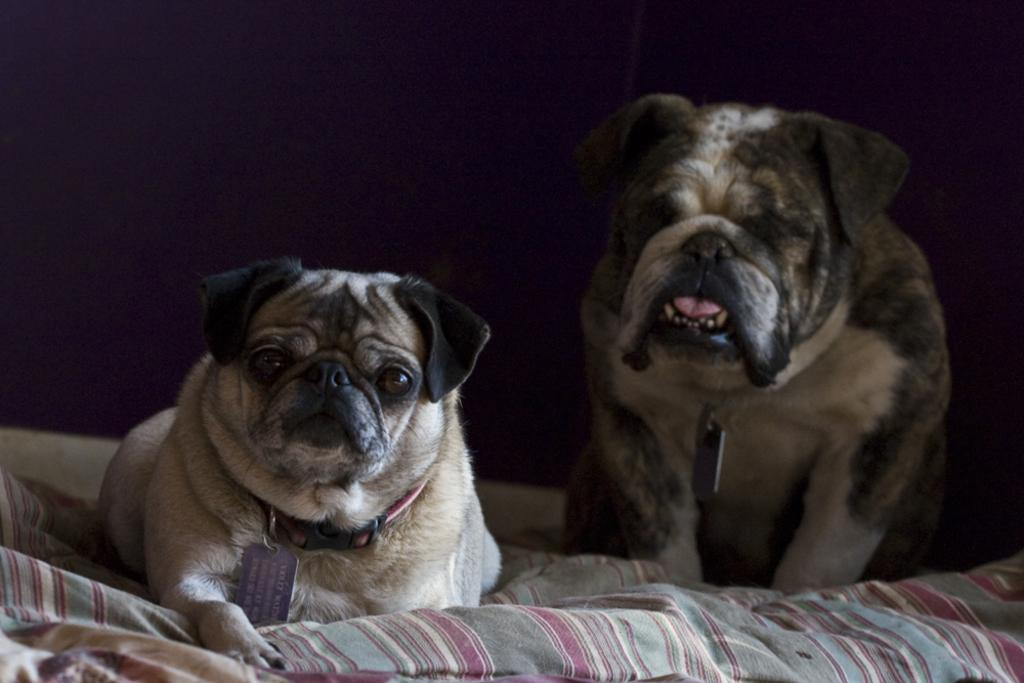What is the color of the background in the image? The background of the image is dark. What type of animals can be seen in the image? There are dogs in the image. What else is present in the image besides the dogs? There are objects and a blanket in the image. What type of grain is being harvested by the dogs in the image? There is no grain or harvesting activity present in the image; it features dogs and other objects. What force is being applied by the dogs in the image? There is no force being applied by the dogs in the image; they are simply present in the scene. 